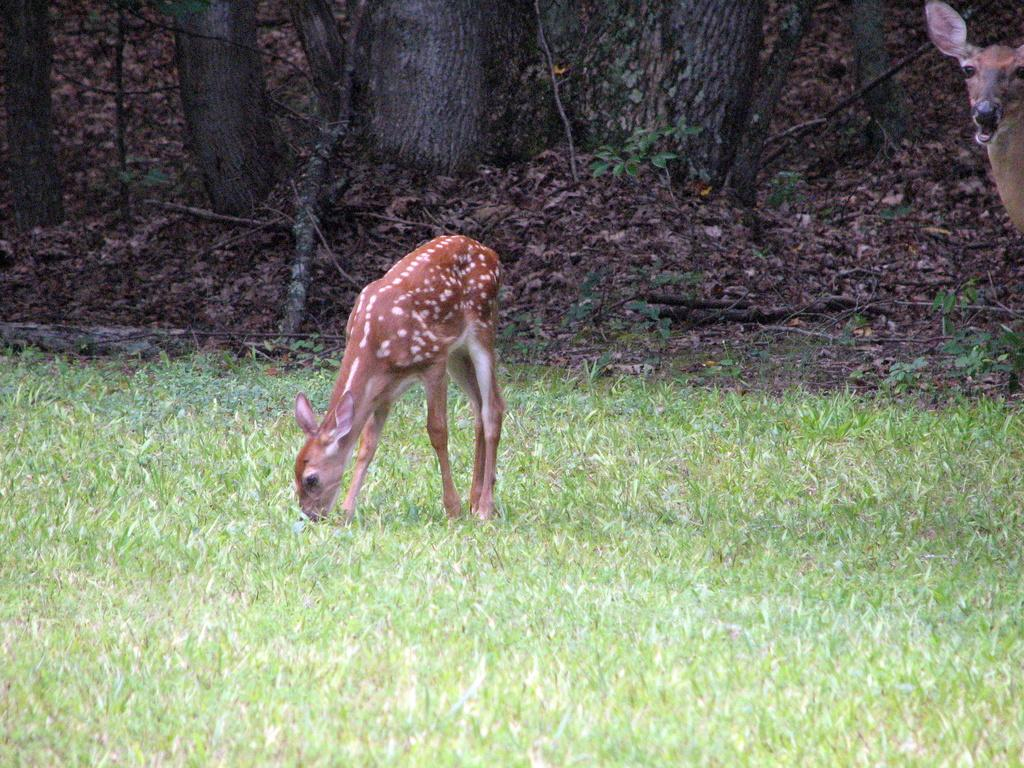What animal can be seen in the image? There is a deer in the image. Where is the deer located? The deer is standing on the grass. What can be seen in the background of the image? Wooden sticks, shredded leaves, and trunks of trees are visible in the background of the image. What type of canvas is the deer painting on in the image? There is no canvas or painting activity present in the image; it features a deer standing on grass. What dish is the deer eating for dinner in the image? There is no dinner or eating activity present in the image; it features a deer standing on grass. 